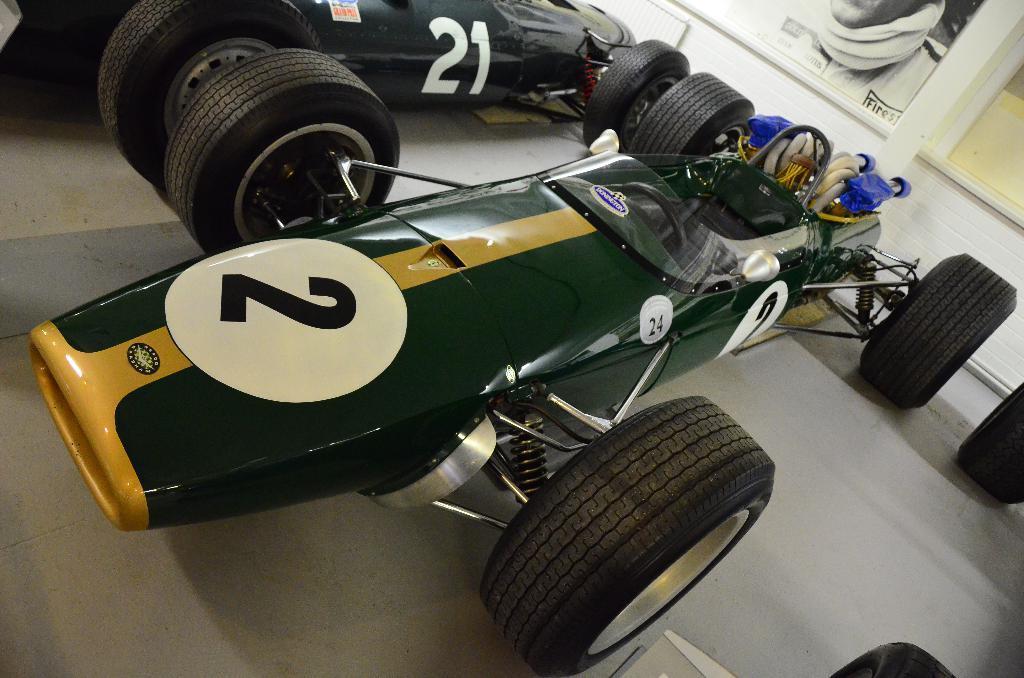How would you summarize this image in a sentence or two? In this image we can see racing cars. In the background there is a wall and we can see boards. 